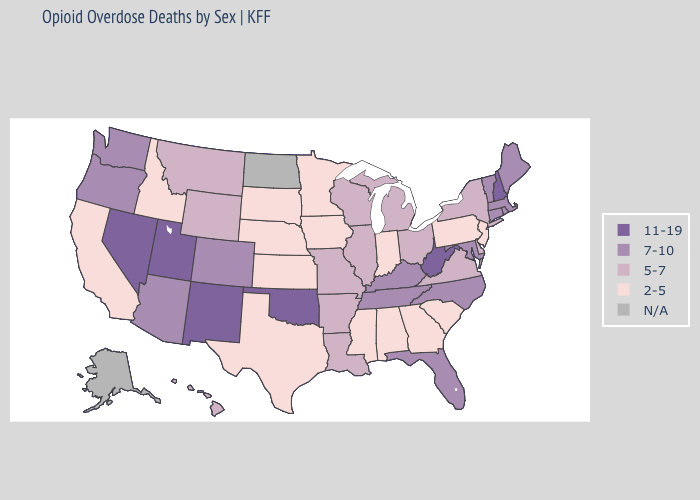Among the states that border Missouri , does Arkansas have the lowest value?
Answer briefly. No. What is the highest value in the USA?
Quick response, please. 11-19. What is the value of California?
Write a very short answer. 2-5. Among the states that border Kansas , does Oklahoma have the highest value?
Keep it brief. Yes. Does the first symbol in the legend represent the smallest category?
Short answer required. No. Among the states that border Utah , which have the highest value?
Give a very brief answer. Nevada, New Mexico. Name the states that have a value in the range 2-5?
Answer briefly. Alabama, California, Georgia, Idaho, Indiana, Iowa, Kansas, Minnesota, Mississippi, Nebraska, New Jersey, Pennsylvania, South Carolina, South Dakota, Texas. Name the states that have a value in the range N/A?
Concise answer only. Alaska, North Dakota. What is the highest value in states that border Oregon?
Short answer required. 11-19. What is the value of New Mexico?
Quick response, please. 11-19. Does Idaho have the lowest value in the West?
Short answer required. Yes. What is the value of Wyoming?
Be succinct. 5-7. What is the lowest value in the USA?
Concise answer only. 2-5. Which states hav the highest value in the MidWest?
Be succinct. Illinois, Michigan, Missouri, Ohio, Wisconsin. What is the value of Montana?
Concise answer only. 5-7. 